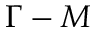<formula> <loc_0><loc_0><loc_500><loc_500>\Gamma - M</formula> 